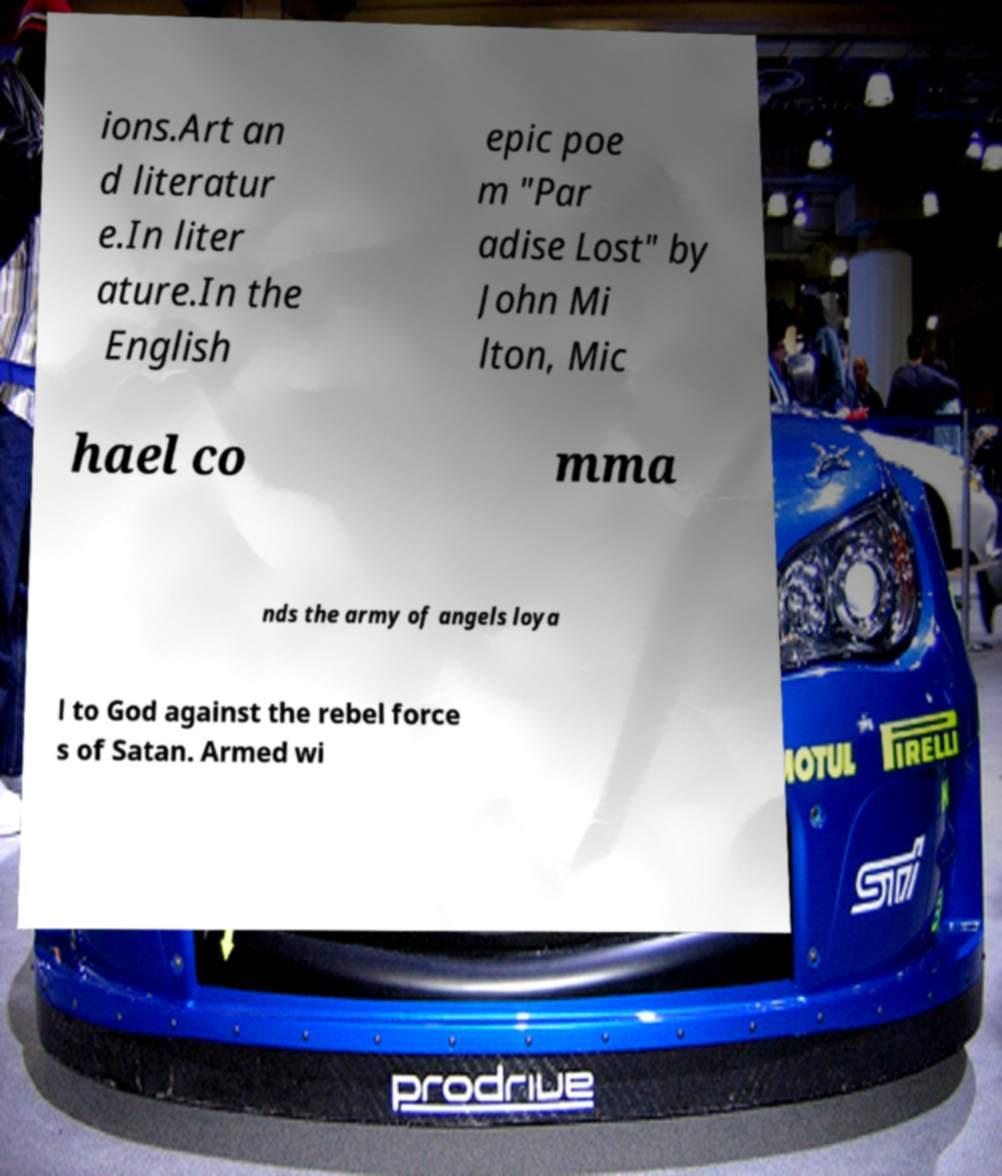Could you assist in decoding the text presented in this image and type it out clearly? ions.Art an d literatur e.In liter ature.In the English epic poe m "Par adise Lost" by John Mi lton, Mic hael co mma nds the army of angels loya l to God against the rebel force s of Satan. Armed wi 